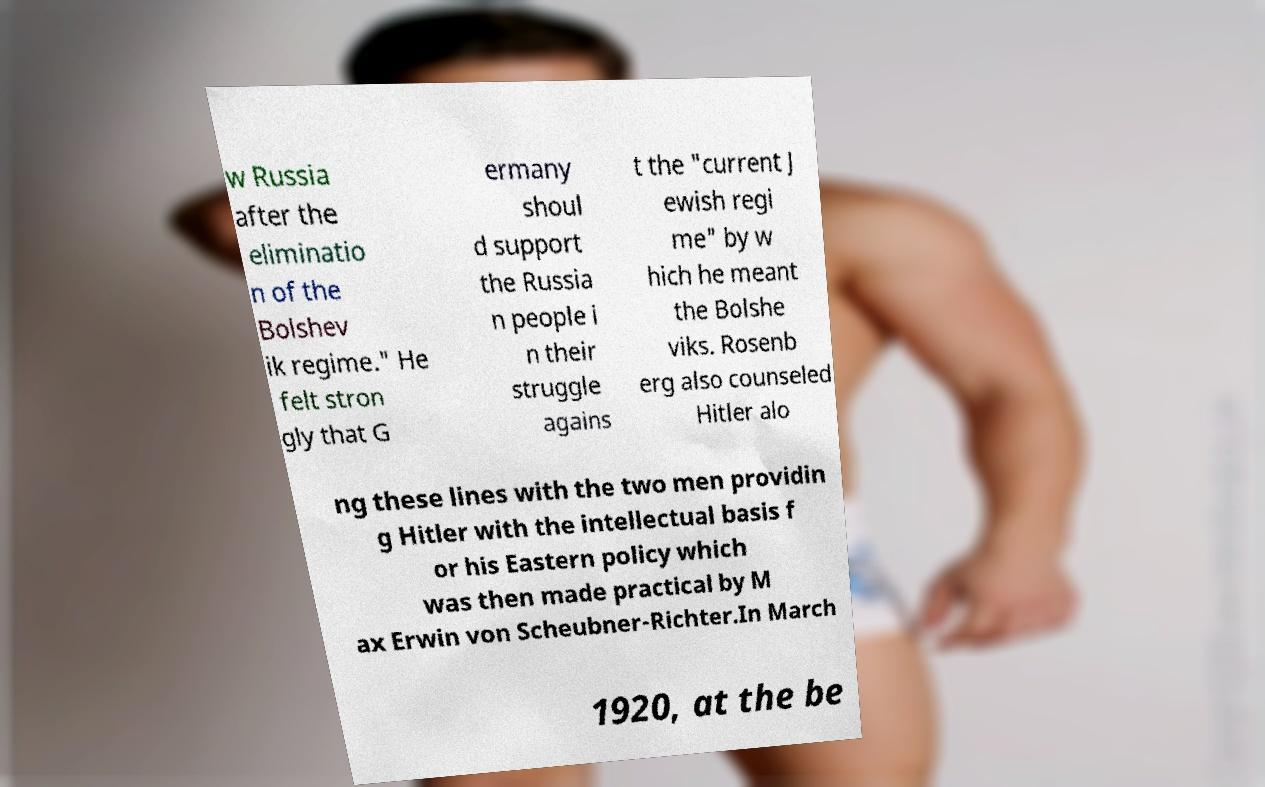There's text embedded in this image that I need extracted. Can you transcribe it verbatim? w Russia after the eliminatio n of the Bolshev ik regime." He felt stron gly that G ermany shoul d support the Russia n people i n their struggle agains t the "current J ewish regi me" by w hich he meant the Bolshe viks. Rosenb erg also counseled Hitler alo ng these lines with the two men providin g Hitler with the intellectual basis f or his Eastern policy which was then made practical by M ax Erwin von Scheubner-Richter.In March 1920, at the be 